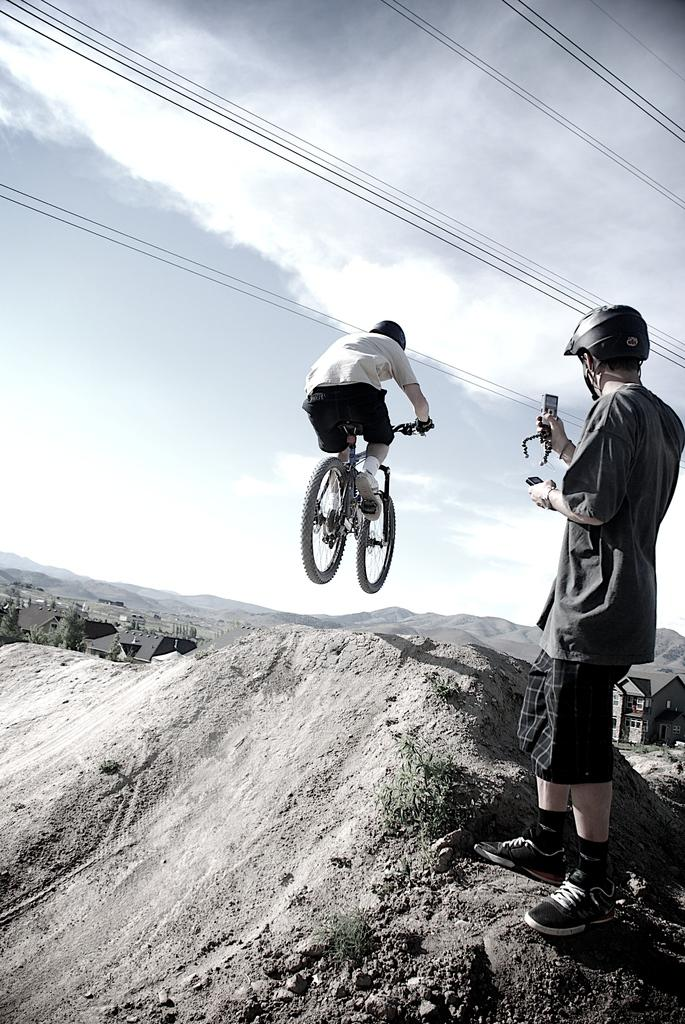What is the main subject of the image? There is a person standing in the image. Can you describe the unusual activity happening in the image? There is a person riding a bicycle in the air in the image. What can be seen in the background of the image? The sky is visible in the image. Where is the dock located in the image? There is no dock present in the image. What type of minister is depicted in the image? There is no minister present in the image. 